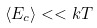Convert formula to latex. <formula><loc_0><loc_0><loc_500><loc_500>\left \langle E _ { c } \right \rangle < < k T</formula> 